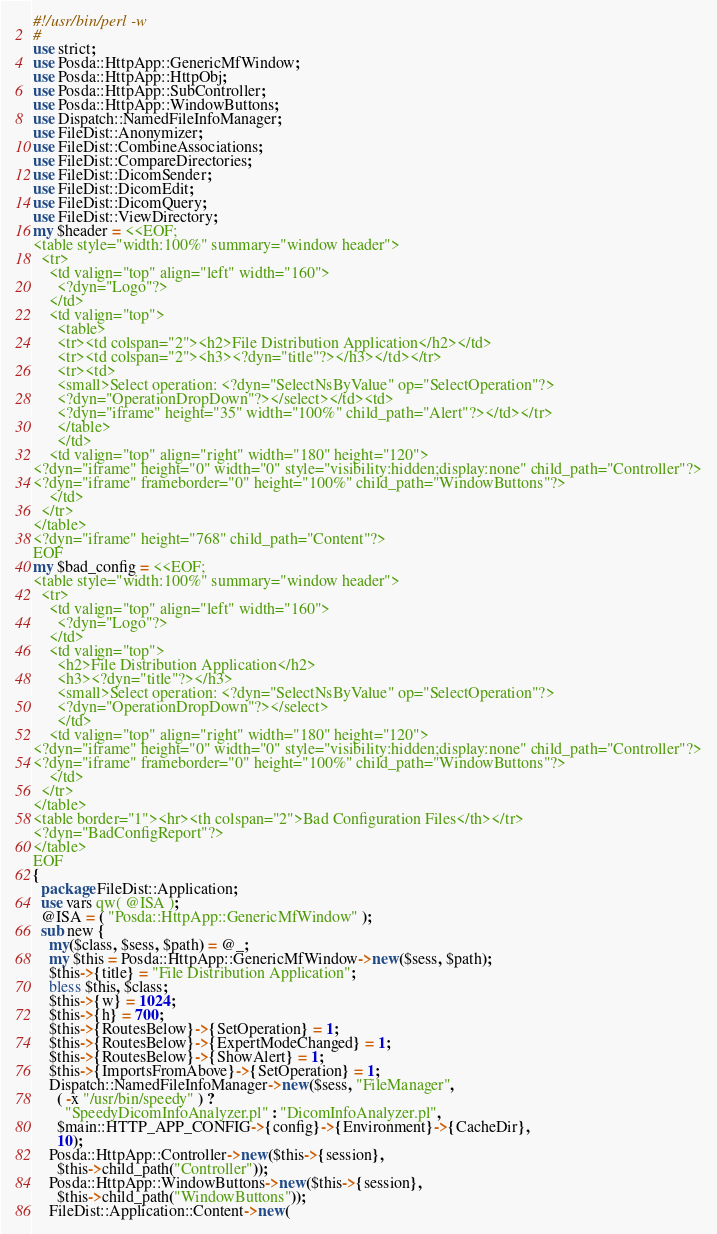<code> <loc_0><loc_0><loc_500><loc_500><_Perl_>#!/usr/bin/perl -w
#
use strict;
use Posda::HttpApp::GenericMfWindow;
use Posda::HttpApp::HttpObj;
use Posda::HttpApp::SubController;
use Posda::HttpApp::WindowButtons;
use Dispatch::NamedFileInfoManager;
use FileDist::Anonymizer;
use FileDist::CombineAssociations;
use FileDist::CompareDirectories;
use FileDist::DicomSender;
use FileDist::DicomEdit;
use FileDist::DicomQuery;
use FileDist::ViewDirectory;
my $header = <<EOF;
<table style="width:100%" summary="window header">
  <tr>
    <td valign="top" align="left" width="160">
      <?dyn="Logo"?>
    </td>
    <td valign="top">
      <table>
      <tr><td colspan="2"><h2>File Distribution Application</h2></td>
      <tr><td colspan="2"><h3><?dyn="title"?></h3></td></tr>
      <tr><td>
      <small>Select operation: <?dyn="SelectNsByValue" op="SelectOperation"?>
      <?dyn="OperationDropDown"?></select></td><td>
      <?dyn="iframe" height="35" width="100%" child_path="Alert"?></td></tr>
      </table>
      </td>
    <td valign="top" align="right" width="180" height="120">
<?dyn="iframe" height="0" width="0" style="visibility:hidden;display:none" child_path="Controller"?>
<?dyn="iframe" frameborder="0" height="100%" child_path="WindowButtons"?>
    </td>
  </tr>
</table>
<?dyn="iframe" height="768" child_path="Content"?>
EOF
my $bad_config = <<EOF;
<table style="width:100%" summary="window header">
  <tr>
    <td valign="top" align="left" width="160">
      <?dyn="Logo"?>
    </td>
    <td valign="top">
      <h2>File Distribution Application</h2>
      <h3><?dyn="title"?></h3>
      <small>Select operation: <?dyn="SelectNsByValue" op="SelectOperation"?>
      <?dyn="OperationDropDown"?></select>
      </td>
    <td valign="top" align="right" width="180" height="120">
<?dyn="iframe" height="0" width="0" style="visibility:hidden;display:none" child_path="Controller"?>
<?dyn="iframe" frameborder="0" height="100%" child_path="WindowButtons"?>
    </td>
  </tr>
</table>
<table border="1"><hr><th colspan="2">Bad Configuration Files</th></tr>
<?dyn="BadConfigReport"?>
</table>
EOF
{
  package FileDist::Application;
  use vars qw( @ISA );
  @ISA = ( "Posda::HttpApp::GenericMfWindow" );
  sub new {
    my($class, $sess, $path) = @_;
    my $this = Posda::HttpApp::GenericMfWindow->new($sess, $path);
    $this->{title} = "File Distribution Application";
    bless $this, $class;
    $this->{w} = 1024;
    $this->{h} = 700;
    $this->{RoutesBelow}->{SetOperation} = 1;
    $this->{RoutesBelow}->{ExpertModeChanged} = 1;
    $this->{RoutesBelow}->{ShowAlert} = 1;
    $this->{ImportsFromAbove}->{SetOperation} = 1;
    Dispatch::NamedFileInfoManager->new($sess, "FileManager",
      ( -x "/usr/bin/speedy" ) ?
        "SpeedyDicomInfoAnalyzer.pl" : "DicomInfoAnalyzer.pl",
      $main::HTTP_APP_CONFIG->{config}->{Environment}->{CacheDir},
      10);
    Posda::HttpApp::Controller->new($this->{session}, 
      $this->child_path("Controller"));
    Posda::HttpApp::WindowButtons->new($this->{session},
      $this->child_path("WindowButtons"));
    FileDist::Application::Content->new(</code> 